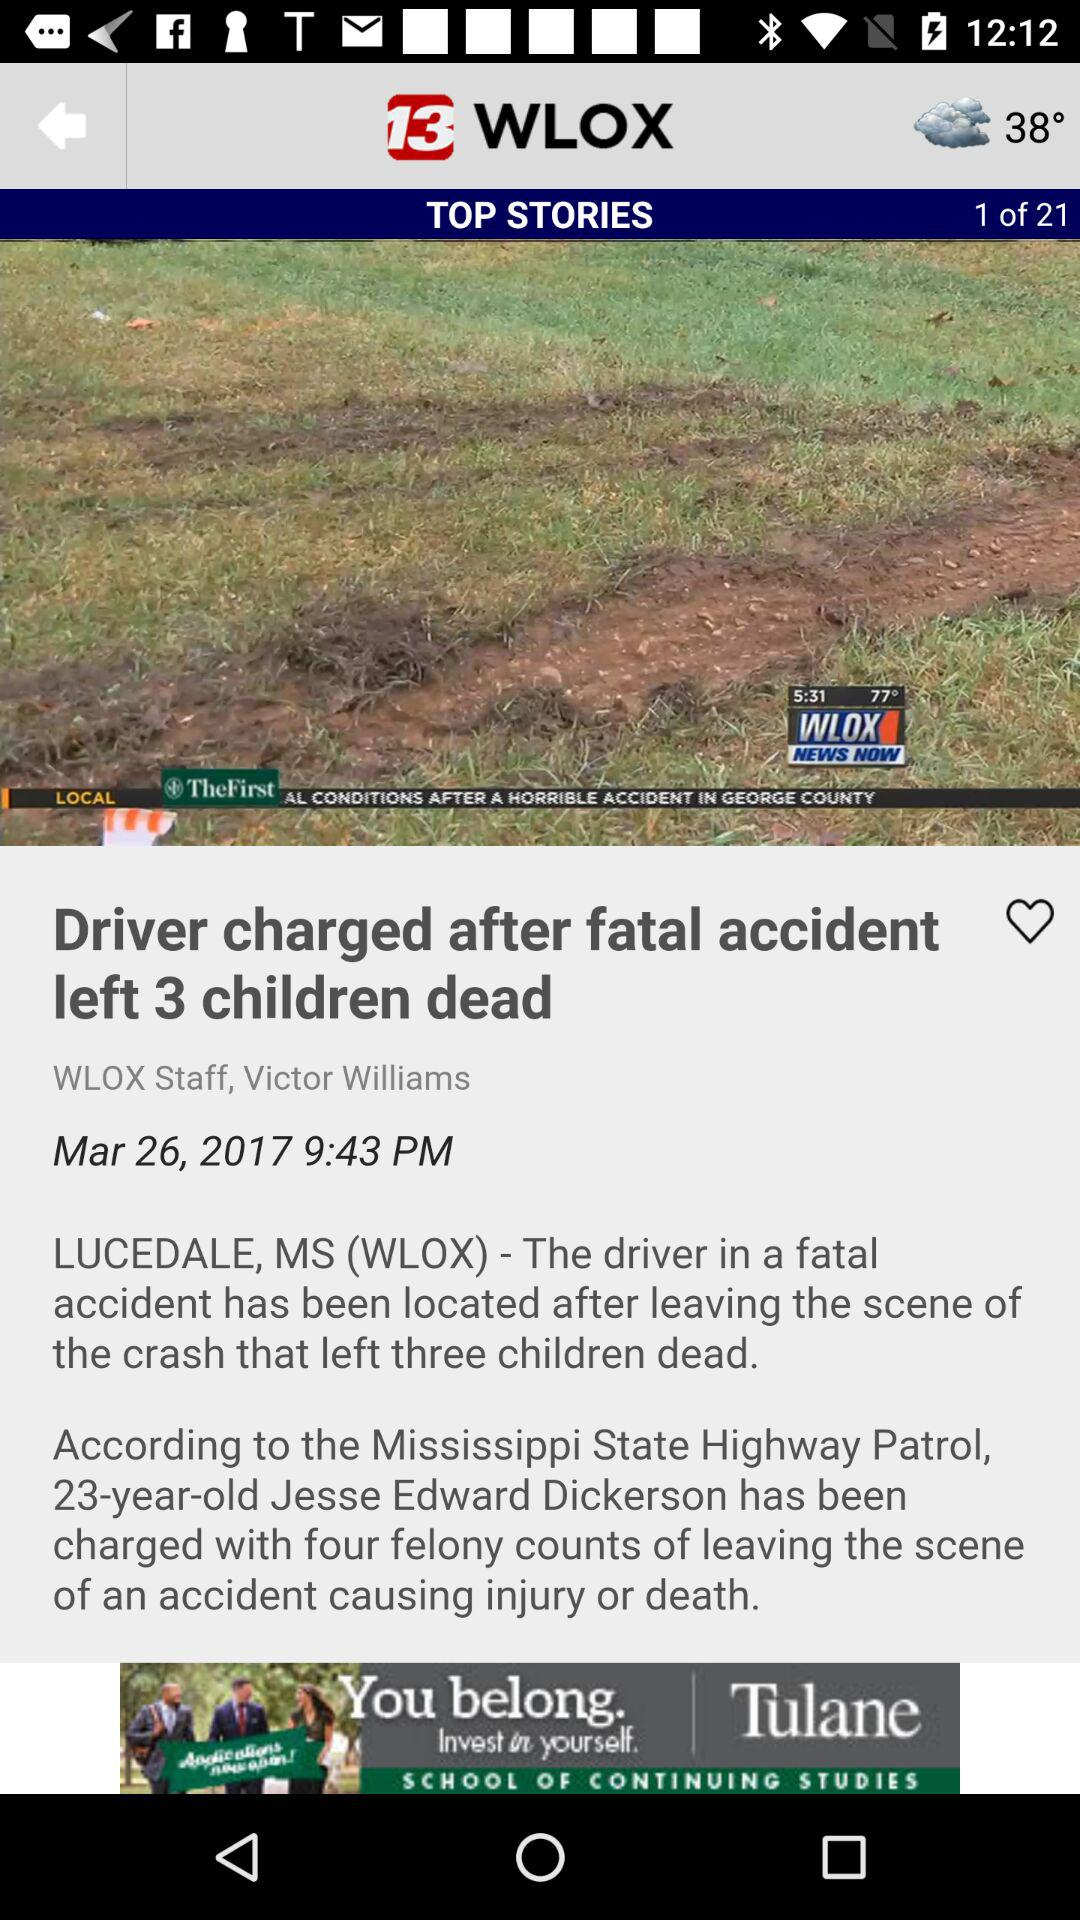What is the name of the application? The name of the application is "WLOX". 